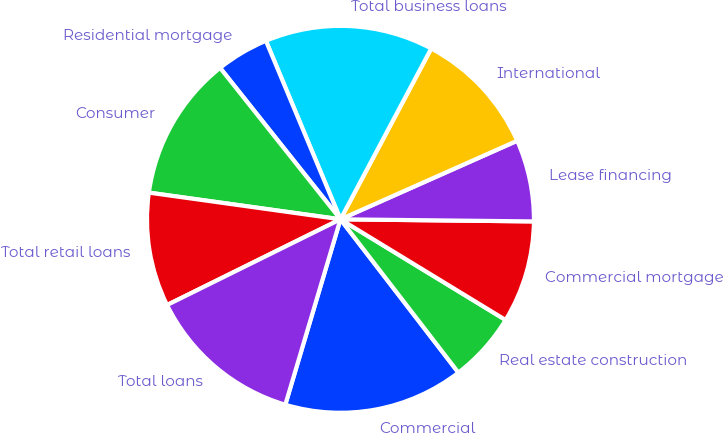Convert chart to OTSL. <chart><loc_0><loc_0><loc_500><loc_500><pie_chart><fcel>Commercial<fcel>Real estate construction<fcel>Commercial mortgage<fcel>Lease financing<fcel>International<fcel>Total business loans<fcel>Residential mortgage<fcel>Consumer<fcel>Total retail loans<fcel>Total loans<nl><fcel>15.04%<fcel>5.85%<fcel>8.54%<fcel>6.83%<fcel>10.57%<fcel>14.07%<fcel>4.39%<fcel>12.11%<fcel>9.51%<fcel>13.09%<nl></chart> 